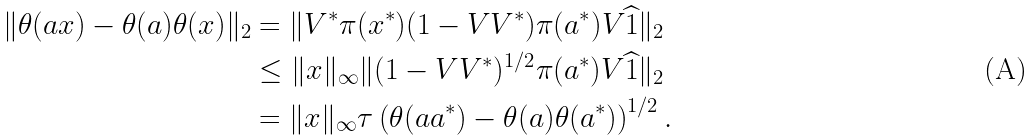Convert formula to latex. <formula><loc_0><loc_0><loc_500><loc_500>\| \theta ( a x ) - \theta ( a ) \theta ( x ) \| _ { 2 } & = \| V ^ { * } \pi ( x ^ { * } ) ( 1 - V V ^ { * } ) \pi ( a ^ { * } ) V \widehat { 1 } \| _ { 2 } \\ & \leq \| x \| _ { \infty } \| ( 1 - V V ^ { * } ) ^ { 1 / 2 } \pi ( a ^ { * } ) V \widehat { 1 } \| _ { 2 } \\ & = \| x \| _ { \infty } \tau \left ( \theta ( a a ^ { * } ) - \theta ( a ) \theta ( a ^ { * } ) \right ) ^ { 1 / 2 } .</formula> 